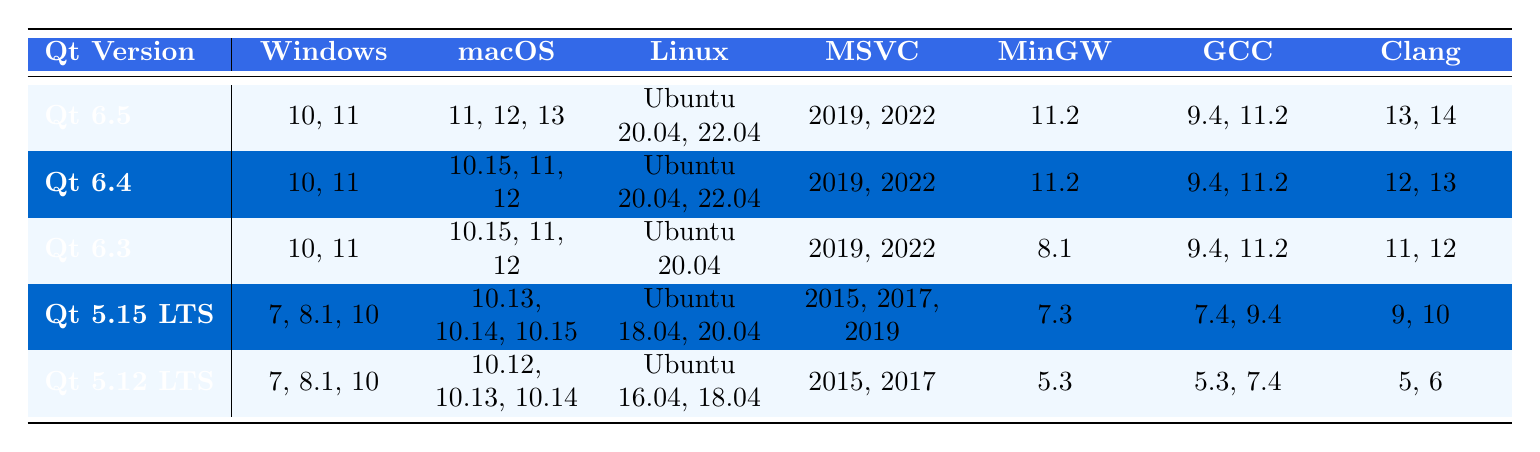What are the supported Windows versions for Qt 6.5? Referring to the table, the Windows versions listed under Qt 6.5 are 10 and 11.
Answer: 10, 11 Which Qt version supports the oldest Windows operating system? Looking at the table, the oldest version listed for Windows is the Qt 5.12 LTS, which supports Windows 7, 8.1, and 10.
Answer: Qt 5.12 LTS Does Qt 6.4 support macOS 10.14? By checking the macOS compatibility for Qt 6.4, it shows support for macOS versions 10.15, 11, and 12, but not 10.14.
Answer: No How many different Linux versions are supported by Qt 5.15 LTS? For Qt 5.15 LTS, the Linux versions listed are Ubuntu 18.04 and 20.04, which makes for a total of 2 distinct versions.
Answer: 2 What is the difference in minimum GCC version support between Qt 5.12 LTS and Qt 6.5? The minimum GCC version for Qt 5.12 LTS is 5.3, while for Qt 6.5 it’s 9.4. The difference between them is 9.4 - 5.3 = 4.1, but since we are comparing versions, it is notable that Qt 6.5 has a higher minimum requirement.
Answer: 4.1 Which Qt version supports the most macOS versions? Analyzing the macOS compatibility, Qt 5.15 LTS supports macOS 10.13, 10.14, and 10.15, while other versions have fewer supported versions. Hence, it supports 3 versions.
Answer: Qt 5.15 LTS Is there a version of Qt that supports Clang 14? Checking in the table, Qt 6.5 is the only version that supports Clang 14.
Answer: Yes Which compiler has the highest version requirement for Qt 6.4? For Qt 6.4, the highest compiler version required is Clang, at version 13, which is the greatest compared to other compilers listed for this version.
Answer: Clang 13 What is the range of MSVC versions supported by Qt 5.15 LTS? The table shows that Qt 5.15 LTS supports MSVC versions 2015, 2017, and 2019. Therefore, the range of supported MSVC versions includes those three years.
Answer: 2015 to 2019 Which operating systems can run Qt 6.3? Qt 6.3 supports Windows 10 and 11, macOS 10.15, 11, and 12, and Linux Ubuntu 20.04. Therefore, those are the operating systems compatible with Qt 6.3.
Answer: Windows 10, 11; macOS 10.15, 11, 12; Linux Ubuntu 20.04 Are there any Qt versions that do not support Windows 10? Reviewing the table, all listed versions of Qt support Windows 10. Thus, there are no versions without this support.
Answer: No 